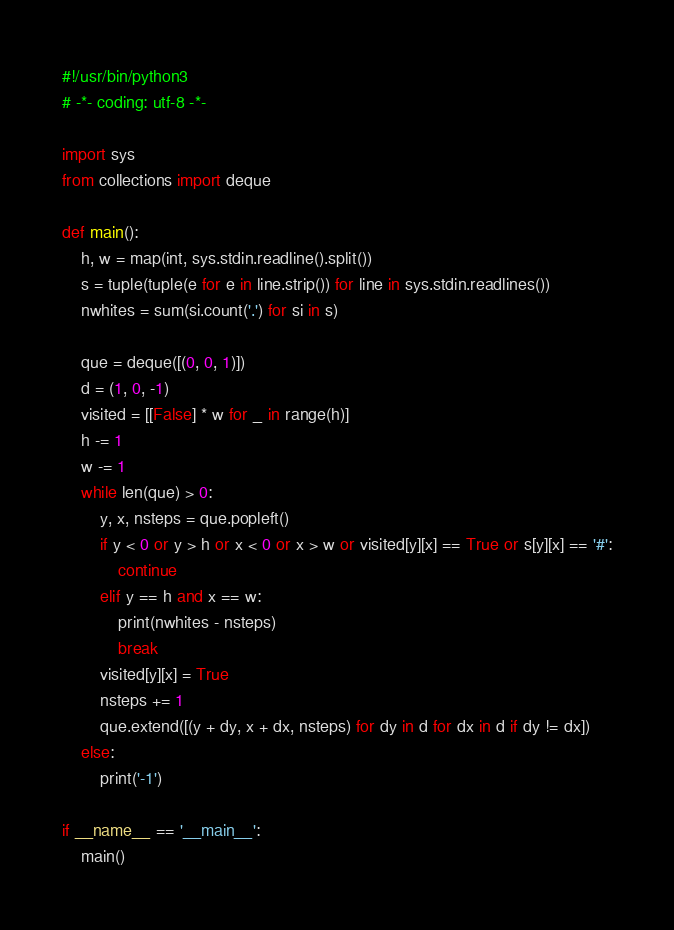<code> <loc_0><loc_0><loc_500><loc_500><_Python_>#!/usr/bin/python3
# -*- coding: utf-8 -*-

import sys
from collections import deque

def main():
    h, w = map(int, sys.stdin.readline().split())
    s = tuple(tuple(e for e in line.strip()) for line in sys.stdin.readlines())
    nwhites = sum(si.count('.') for si in s)

    que = deque([(0, 0, 1)])
    d = (1, 0, -1)
    visited = [[False] * w for _ in range(h)]
    h -= 1
    w -= 1
    while len(que) > 0:
        y, x, nsteps = que.popleft()
        if y < 0 or y > h or x < 0 or x > w or visited[y][x] == True or s[y][x] == '#':
            continue
        elif y == h and x == w:
            print(nwhites - nsteps)
            break
        visited[y][x] = True
        nsteps += 1
        que.extend([(y + dy, x + dx, nsteps) for dy in d for dx in d if dy != dx])
    else:
        print('-1')

if __name__ == '__main__':
    main()
</code> 